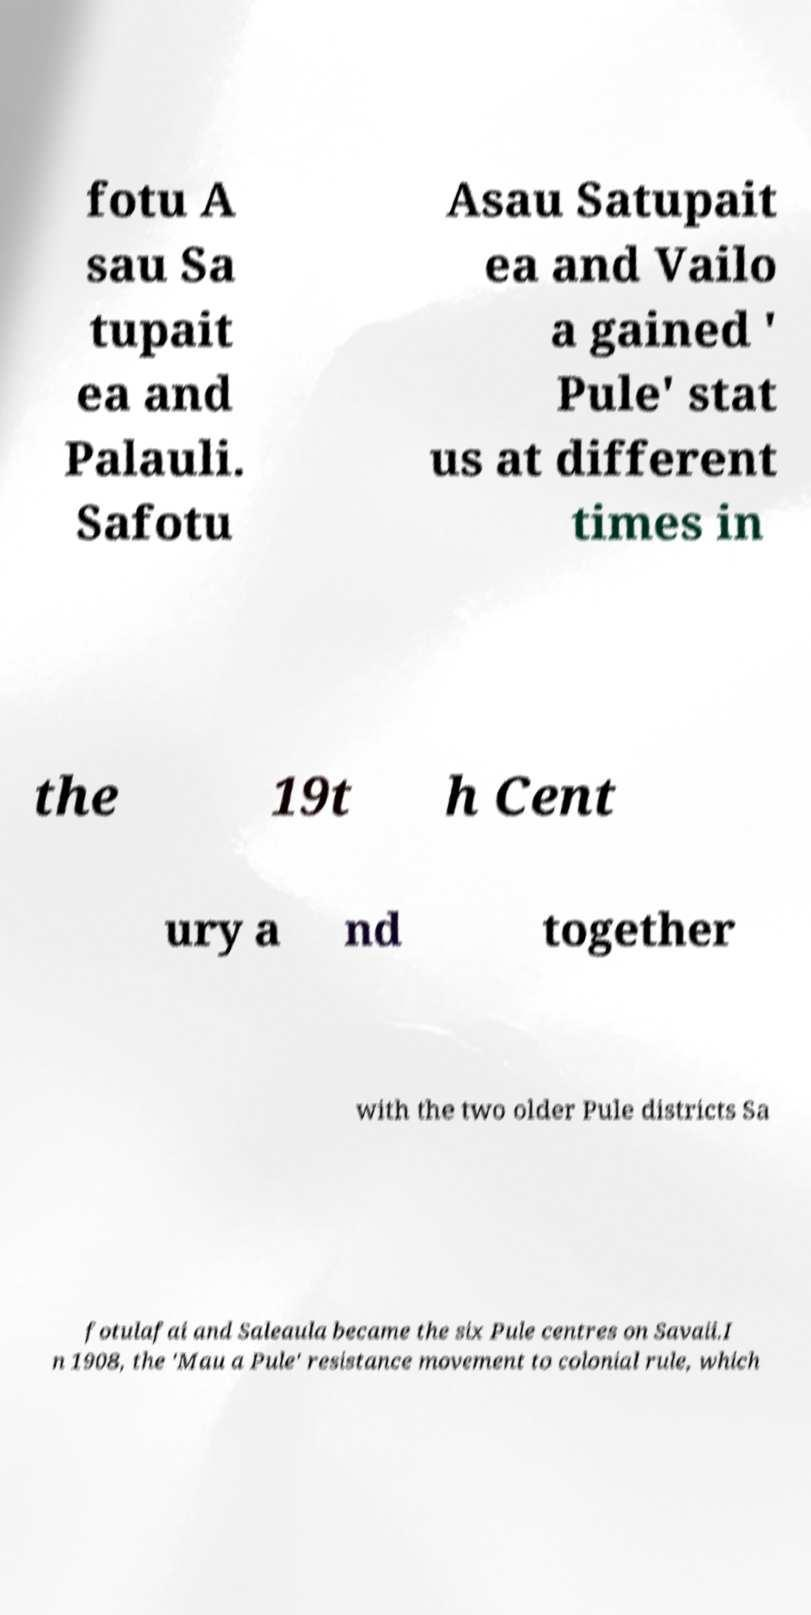I need the written content from this picture converted into text. Can you do that? fotu A sau Sa tupait ea and Palauli. Safotu Asau Satupait ea and Vailo a gained ' Pule' stat us at different times in the 19t h Cent ury a nd together with the two older Pule districts Sa fotulafai and Saleaula became the six Pule centres on Savaii.I n 1908, the 'Mau a Pule' resistance movement to colonial rule, which 